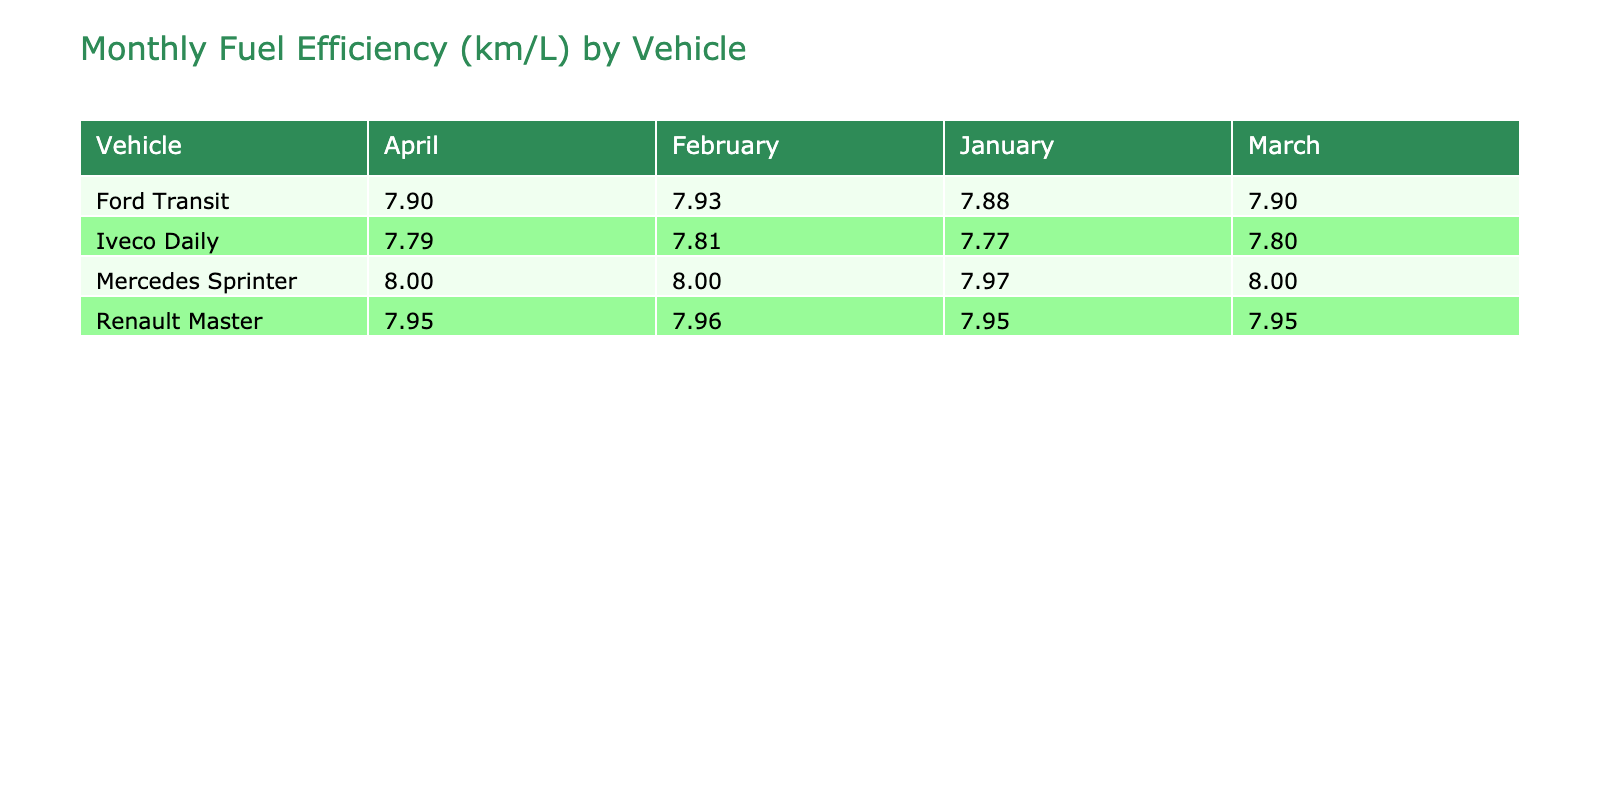What is the fuel efficiency of the Ford Transit in March? In the table, under the Ford Transit row and the March column, the fuel efficiency value listed is 7.90 km/L.
Answer: 7.90 km/L Which vehicle had the highest fuel efficiency in February? Looking at the February column, the vehicle with the highest efficiency is the Mercedes Sprinter at 8.00 km/L.
Answer: Mercedes Sprinter What is the average fuel efficiency for the Renault Master over the four months? The efficiencies for Renault Master from January to April are 7.95, 7.96, 7.95, and 7.95 km/L. The sum is 31.81 km/L, and dividing by 4 gives an average of 7.95 km/L.
Answer: 7.95 km/L Did the efficiency of Iveco Daily increase or decrease from January to April? The efficiencies for Iveco Daily are 7.77 km/L in January and 7.79 km/L in April. Since 7.79 is greater than 7.77, the efficiency increased.
Answer: Increased What was the total fuel consumption for the Ford Transit in the first quarter (January to March)? The fuel consumptions for Ford Transit in the first quarter are 412 L in January, 398 L in February, and 425 L in March. Summing these values gives 412 + 398 + 425 = 1235 L.
Answer: 1235 L Which vehicle showed the most consistent efficiency across the four months? Evaluating the efficiencies for each vehicle reveals that the Ford Transit had values of 7.88, 7.93, 7.90, and 7.90 km/L. The range is only 0.05 km/L. Compared to others, this shows the most consistency.
Answer: Ford Transit What is the percentage increase in fuel efficiency of the Mercedes Sprinter from January to February? The efficiency for Mercedes Sprinter in January is 7.97 km/L and in February it is 8.00 km/L. The increase is 8.00 - 7.97 = 0.03 km/L. The percentage increase is (0.03 / 7.97) * 100 = 0.38%.
Answer: 0.38% Which month had the lowest overall average fuel efficiency across all vehicles? The monthly averages are calculated as follows: January average = (7.88 + 7.97 + 7.95 + 7.77) / 4 = 7.89 km/L, February average = (7.93 + 8.00 + 7.96 + 7.81) / 4 = 7.93 km/L, March average = (7.90 + 8.00 + 7.95 + 7.80) / 4 = 7.91 km/L, April average = (7.90 + 8.00 + 7.95 + 7.79) / 4 = 7.91 km/L. January has the lowest average at 7.89 km/L.
Answer: January What is the difference in efficiency between the vehicle with the highest efficiency and the one with the lowest efficiency in April? In April, the highest efficiency is for Mercedes Sprinter at 8.00 km/L and the lowest is for Iveco Daily at 7.79 km/L. The difference is 8.00 - 7.79 = 0.21 km/L.
Answer: 0.21 km/L 